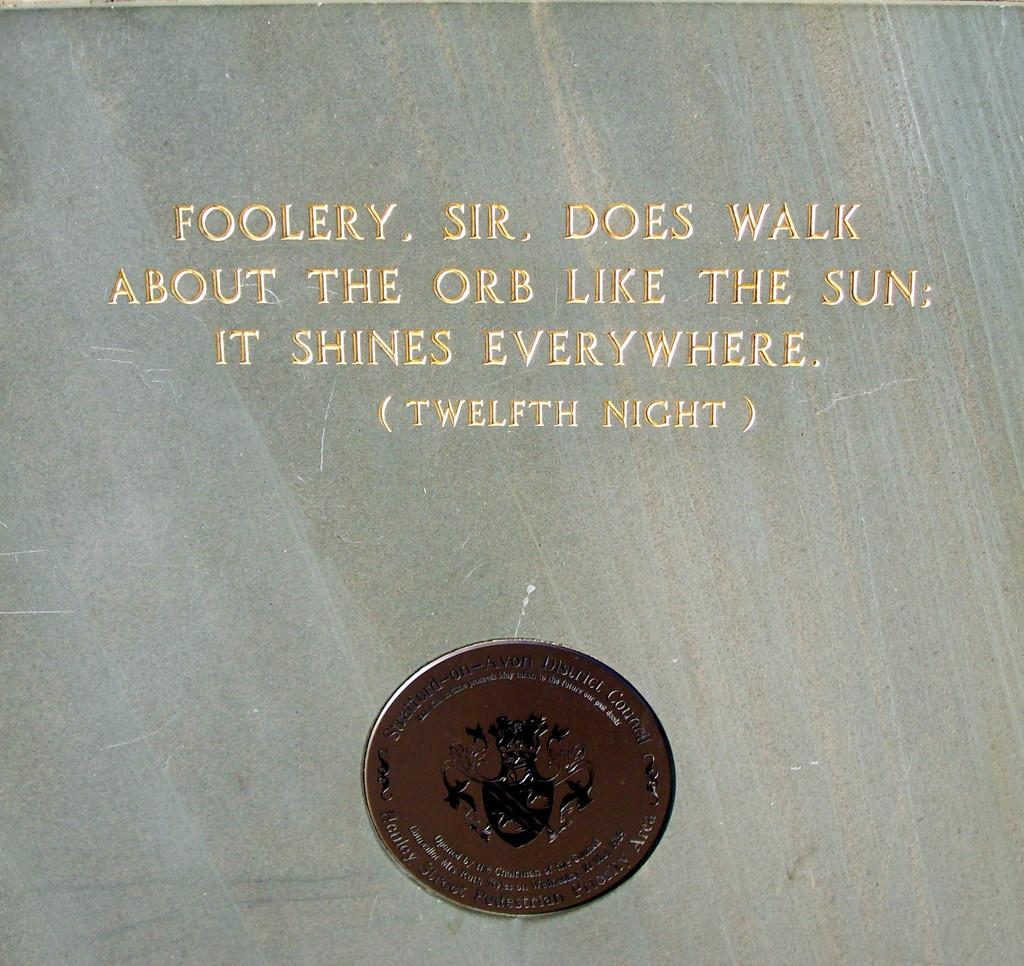<image>
Relay a brief, clear account of the picture shown. A copper coin sits below a quote from the Twelfth Night 